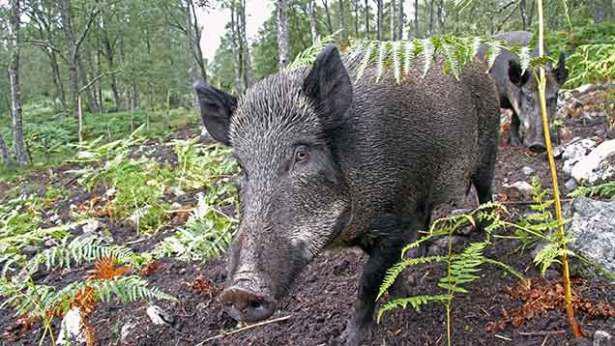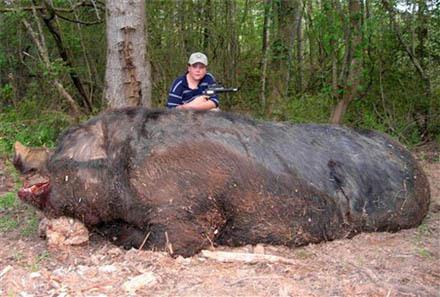The first image is the image on the left, the second image is the image on the right. Evaluate the accuracy of this statement regarding the images: "A weapon is visible next to a dead hog in one image.". Is it true? Answer yes or no. Yes. 